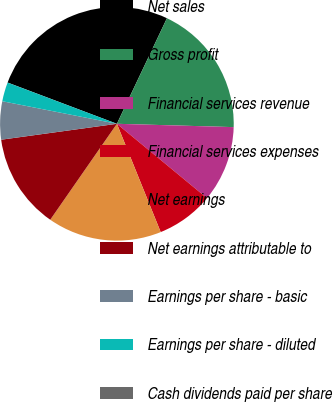Convert chart to OTSL. <chart><loc_0><loc_0><loc_500><loc_500><pie_chart><fcel>Net sales<fcel>Gross profit<fcel>Financial services revenue<fcel>Financial services expenses<fcel>Net earnings<fcel>Net earnings attributable to<fcel>Earnings per share - basic<fcel>Earnings per share - diluted<fcel>Cash dividends paid per share<nl><fcel>26.3%<fcel>18.41%<fcel>10.53%<fcel>7.9%<fcel>15.78%<fcel>13.16%<fcel>5.27%<fcel>2.64%<fcel>0.01%<nl></chart> 